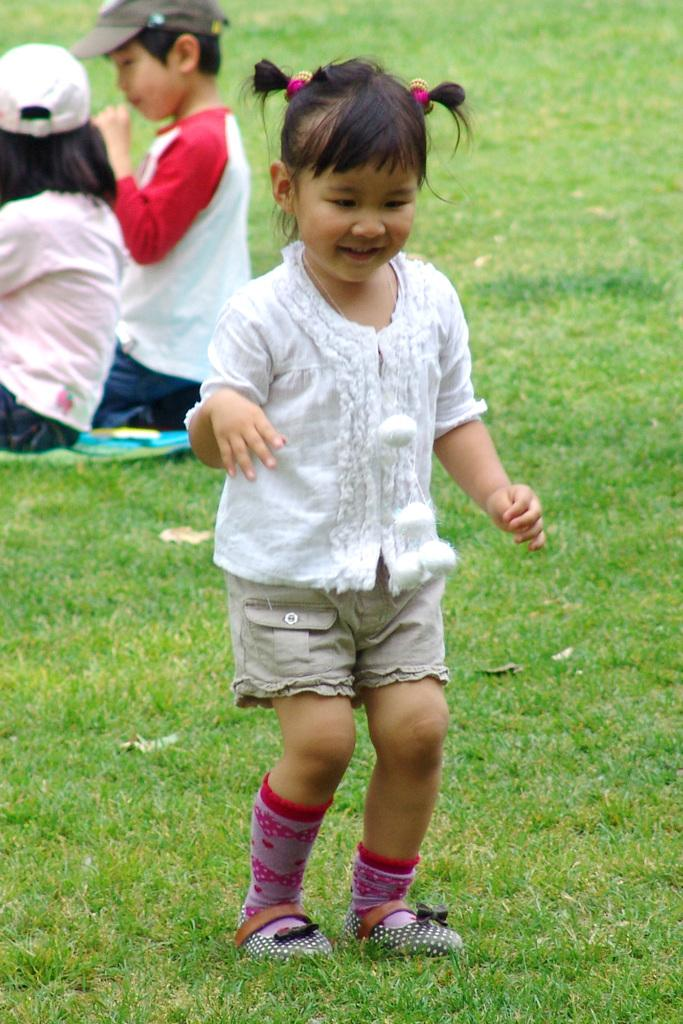What is the main subject of the image? The main subject of the image is a baby girl. What is the baby girl doing in the image? The baby girl is standing on the grass and smiling. Are there any other people in the image? Yes, there are two people sitting on the grass in the image. What crime is the baby girl committing in the image? There is no crime being committed in the image; the baby girl is simply standing on the grass and smiling. What journey is the baby girl taking in the image? There is no journey depicted in the image; the baby girl is standing on the grass and smiling. 